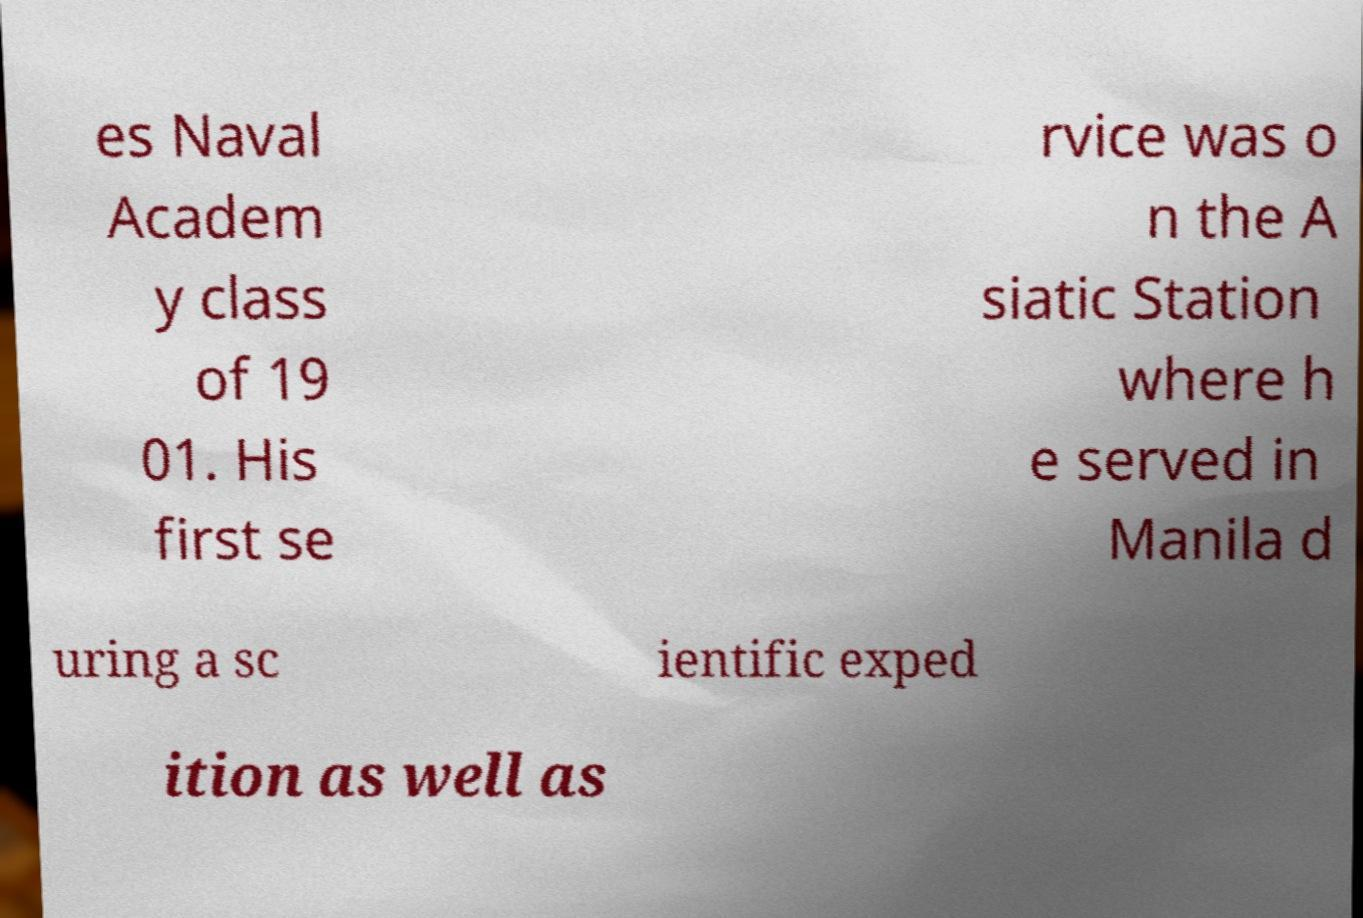Could you assist in decoding the text presented in this image and type it out clearly? es Naval Academ y class of 19 01. His first se rvice was o n the A siatic Station where h e served in Manila d uring a sc ientific exped ition as well as 